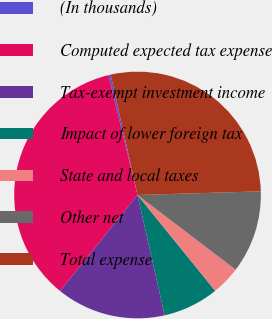Convert chart to OTSL. <chart><loc_0><loc_0><loc_500><loc_500><pie_chart><fcel>(In thousands)<fcel>Computed expected tax expense<fcel>Tax-exempt investment income<fcel>Impact of lower foreign tax<fcel>State and local taxes<fcel>Other net<fcel>Total expense<nl><fcel>0.29%<fcel>35.41%<fcel>14.34%<fcel>7.31%<fcel>3.8%<fcel>10.83%<fcel>28.02%<nl></chart> 